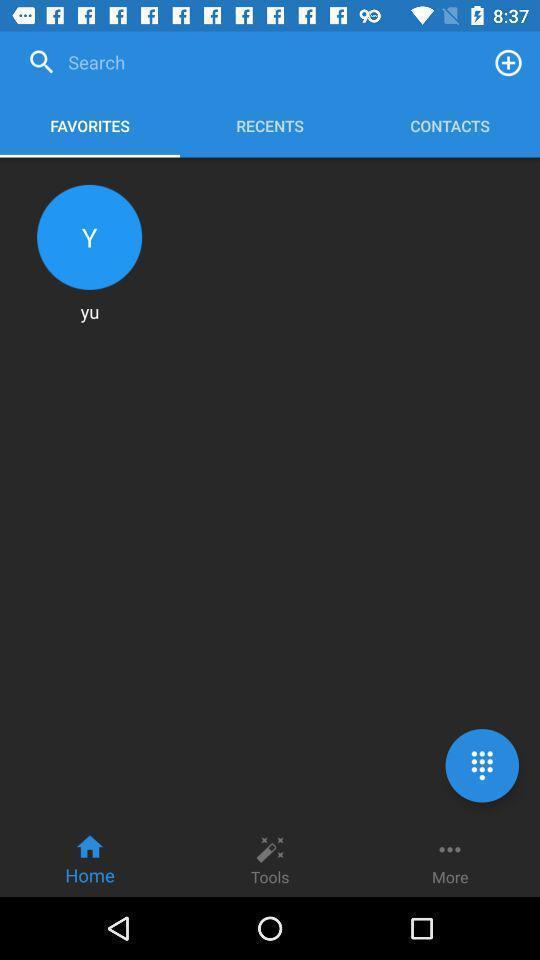Describe the content in this image. Screen shows search favourites option in a call app. 